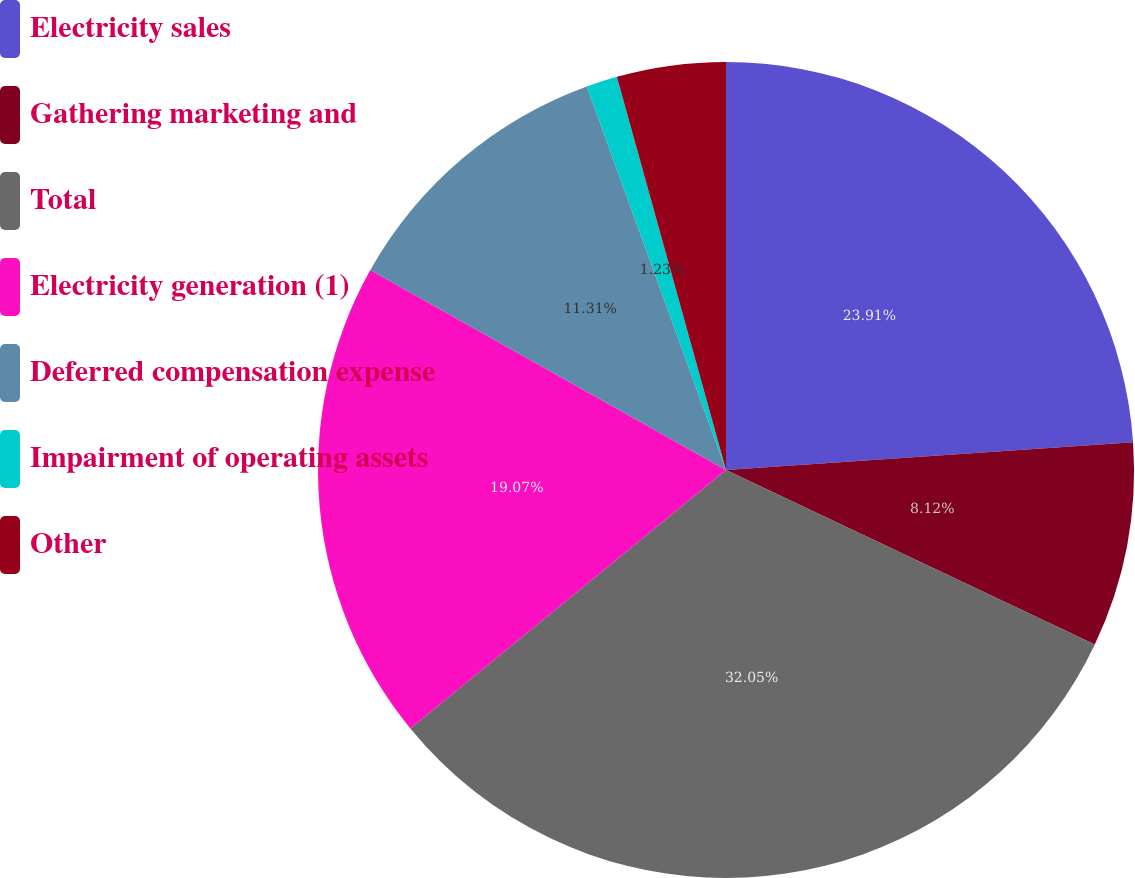<chart> <loc_0><loc_0><loc_500><loc_500><pie_chart><fcel>Electricity sales<fcel>Gathering marketing and<fcel>Total<fcel>Electricity generation (1)<fcel>Deferred compensation expense<fcel>Impairment of operating assets<fcel>Other<nl><fcel>23.91%<fcel>8.12%<fcel>32.04%<fcel>19.07%<fcel>11.31%<fcel>1.23%<fcel>4.31%<nl></chart> 